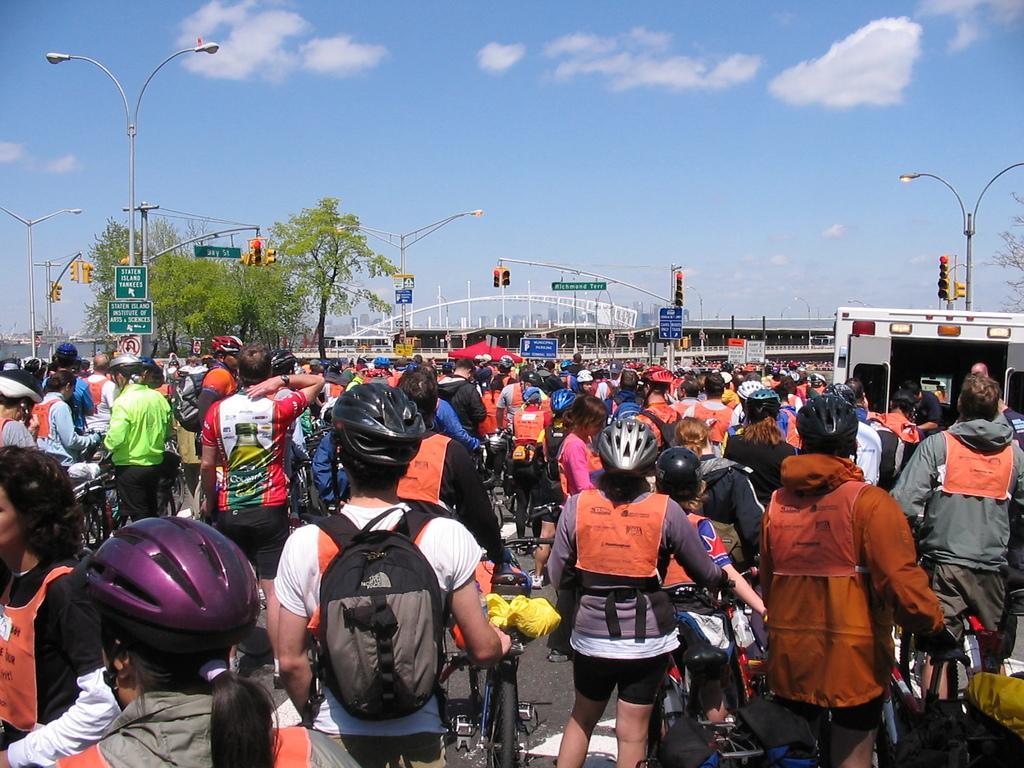Describe this image in one or two sentences. Here we see a group of people standing on road with their bicycles. In the middle of the picture, we see bridge and beside that, we see trees. On the left corner of the picture, we see a pole and street lights. On the right corner of the picture, we see traffic lights and on top of this picture, we see sky and clouds. 